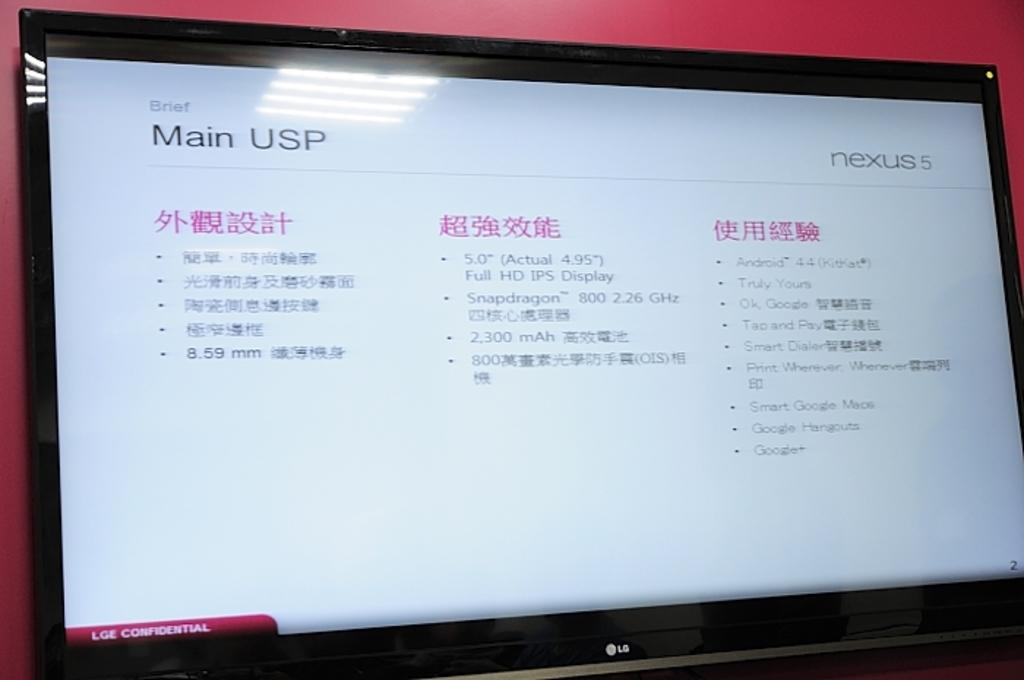<image>
Provide a brief description of the given image. A computer monitor screen showing words in Chinese writing,. 